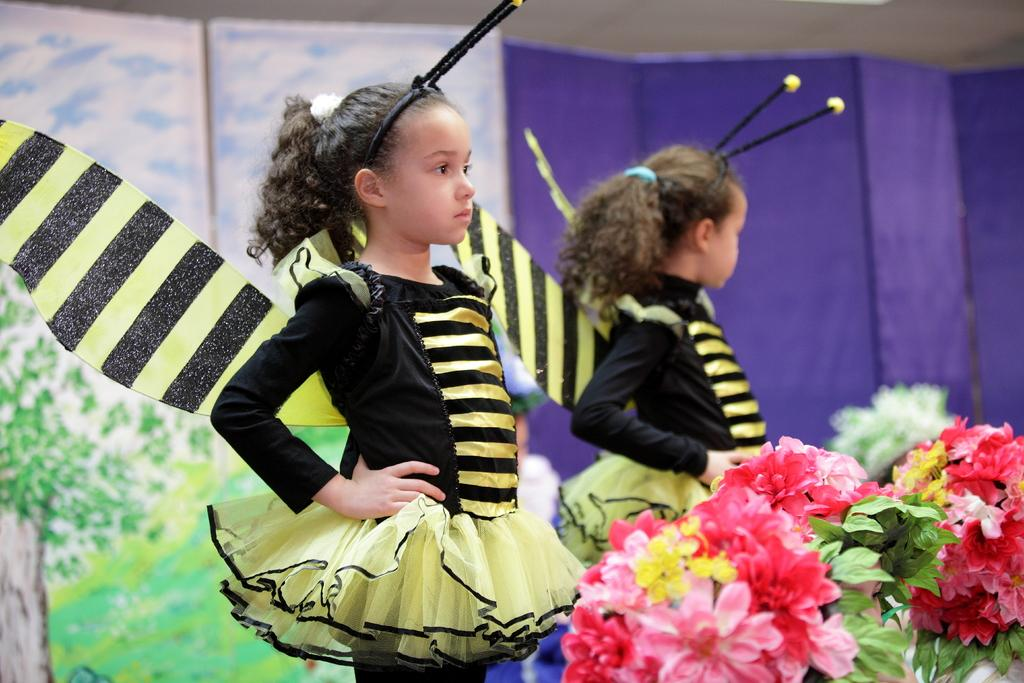What is located in the bottom right hand corner of the image? There are flowers in the bottom right hand corner of the image. How many people are in the image? There are two girls in the image. What are the girls wearing? The girls are wearing fancy dress. What type of surprise can be seen in the image? There is no surprise present in the image; it features flowers in the bottom right hand corner and two girls wearing fancy dress. How do the girls grip the flowers in the image? There is no indication in the image that the girls are holding or gripping the flowers. 